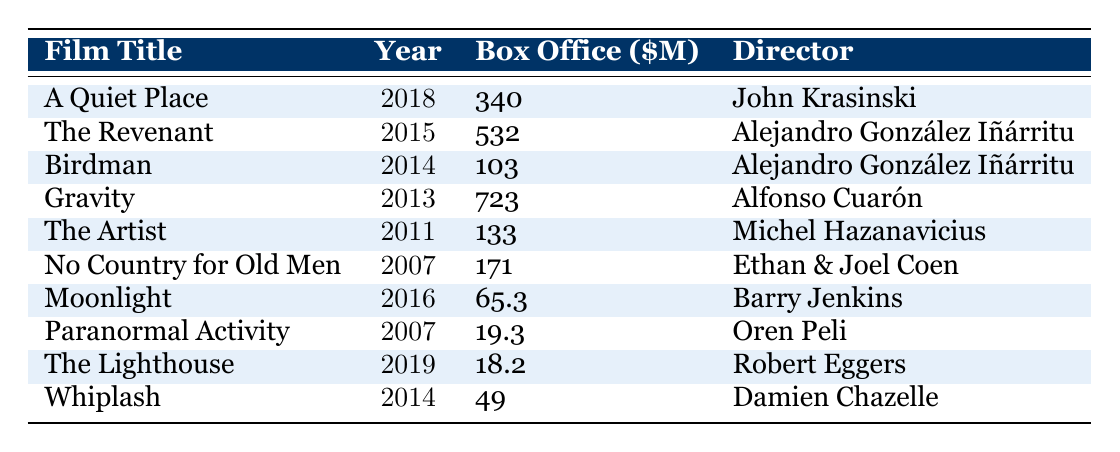What is the title of the film with the highest box office performance in the table? The table lists several films along with their box office numbers. By examining the box office values, "Gravity" has the highest performance at 723 million dollars.
Answer: Gravity Which director has the highest-grossing film based on this table? "Gravity," directed by Alfonso Cuarón, has the highest box office performance of 723 million dollars, making him the director of the highest-grossing film.
Answer: Alfonso Cuarón How many films in the table had minimal music usage? Looking through the music usage column, there are five films listed as having minimal music usage: "A Quiet Place," "Birdman," "The Artist," "No Country for Old Men," and "Paranormal Activity."
Answer: 5 What is the total box office gross for films with minimal music usage? The total box office for films with minimal music is calculated as follows: 340 + 103 + 133 + 171 + 19.3 = 766.3 million dollars.
Answer: 766.3 million dollars Which film released in 2018 had minimal music usage? The film "A Quiet Place," released in 2018, is identified in the table as having minimal music usage.
Answer: A Quiet Place Calculate the average box office performance of films with sparse music usage. The films with sparse music usage are "The Revenant" (532 million) and "Moonlight" (65.3 million). The total is 532 + 65.3 = 597.3 million. The average is 597.3 / 2 = 298.65 million.
Answer: 298.65 million Is there any film in the table that combines drama and horror genres? "The Lighthouse" is tagged under the drama/horror genre in the table, confirming there is such a film listed.
Answer: Yes What is the box office gross of the film "Whiplash"? According to the table, "Whiplash" has a box office performance of 49 million dollars.
Answer: 49 million dollars Which genres are most represented among the films listed? By analyzing the genres, drama is mentioned at least four times ("Moonlight," "Whiplash," "The Revenant," and "Birdman") making it the most represented genre among the films listed.
Answer: Drama Identify all the films directed by Alejandro González Iñárritu. The films directed by Alejandro González Iñárritu in the table are "The Revenant" and "Birdman."
Answer: The Revenant and Birdman 